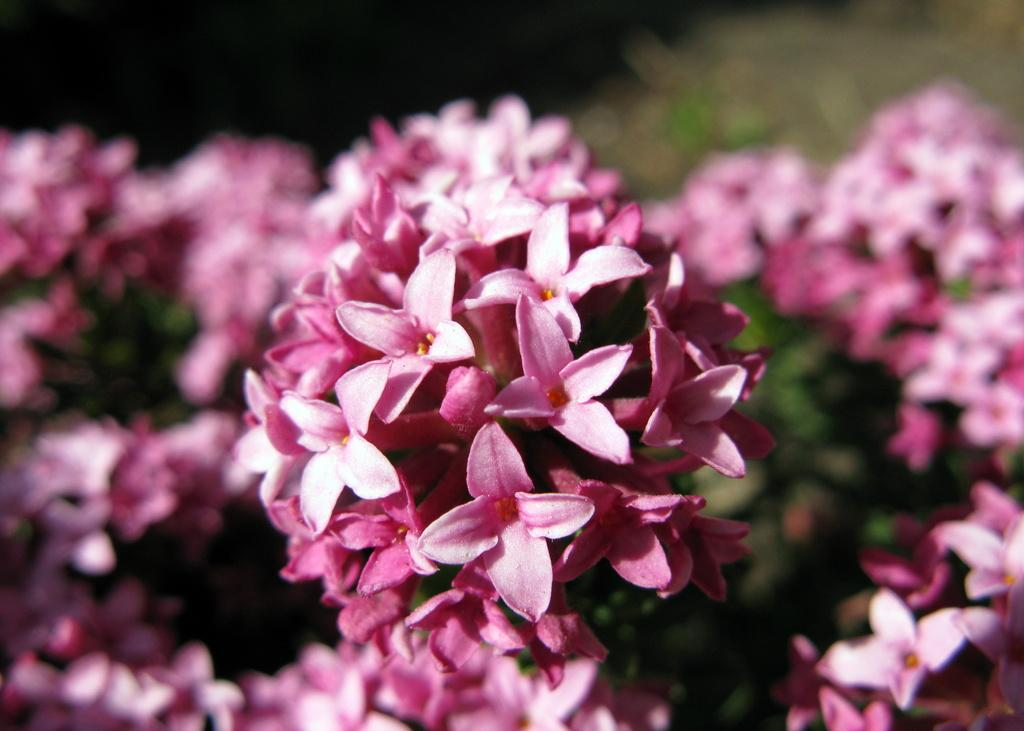What type of living organisms can be seen in the image? There are flowers in the image. What color is the background of the image? The background of the image is blue. What type of tooth can be seen in the image? There is no tooth present in the image; it features flowers and a blue background. How many robins are visible in the image? There are no robins present in the image; it features flowers and a blue background. 